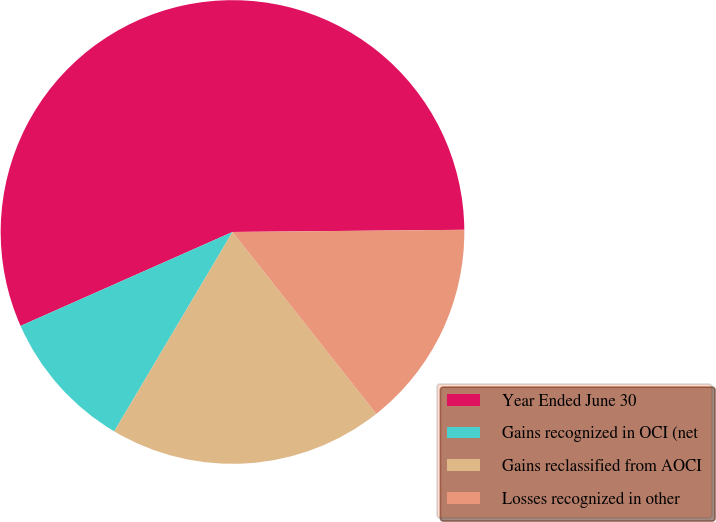Convert chart. <chart><loc_0><loc_0><loc_500><loc_500><pie_chart><fcel>Year Ended June 30<fcel>Gains recognized in OCI (net<fcel>Gains reclassified from AOCI<fcel>Losses recognized in other<nl><fcel>56.49%<fcel>9.84%<fcel>19.17%<fcel>14.5%<nl></chart> 